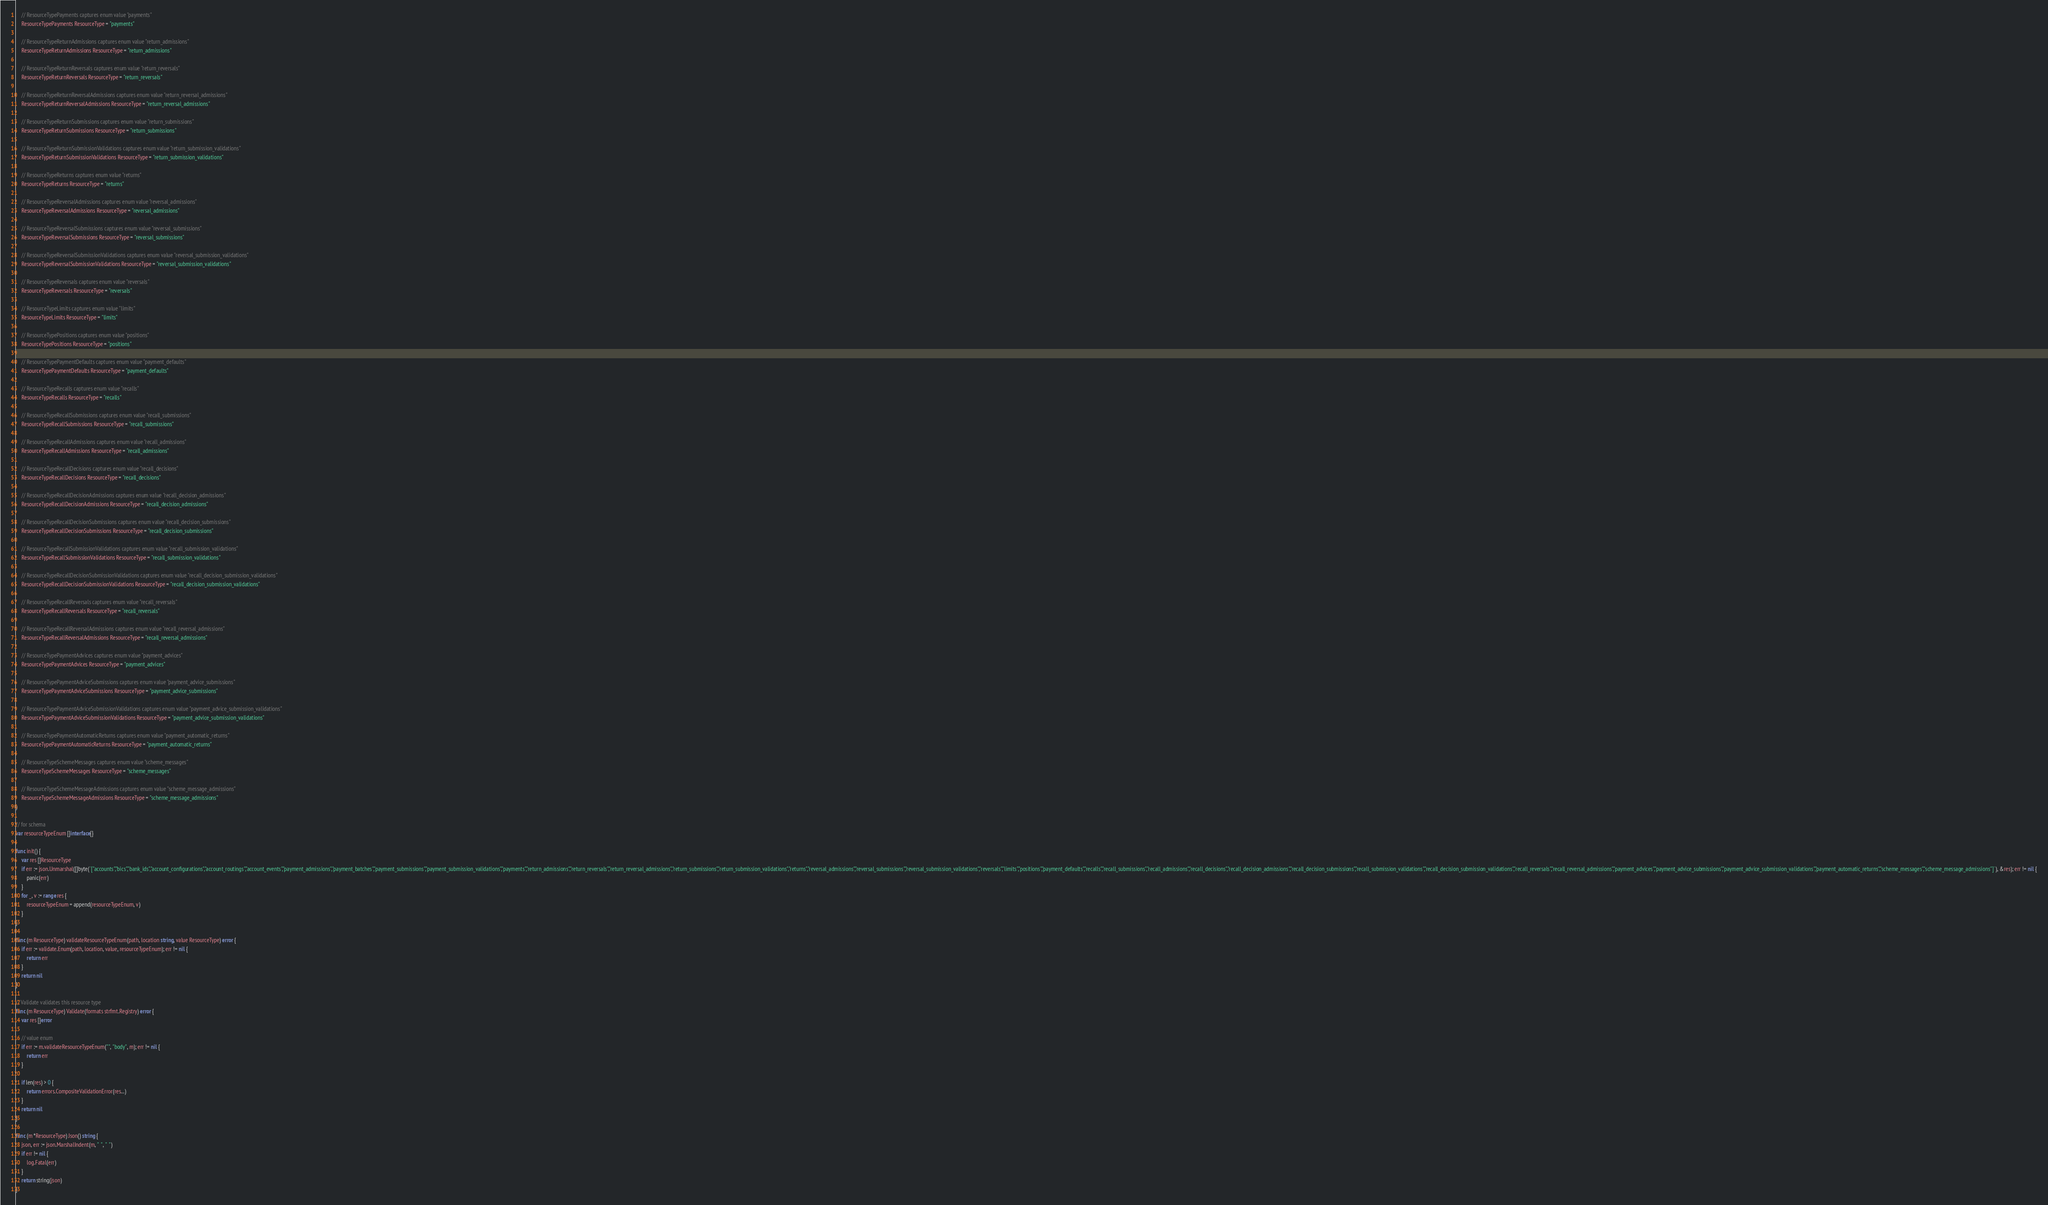<code> <loc_0><loc_0><loc_500><loc_500><_Go_>
	// ResourceTypePayments captures enum value "payments"
	ResourceTypePayments ResourceType = "payments"

	// ResourceTypeReturnAdmissions captures enum value "return_admissions"
	ResourceTypeReturnAdmissions ResourceType = "return_admissions"

	// ResourceTypeReturnReversals captures enum value "return_reversals"
	ResourceTypeReturnReversals ResourceType = "return_reversals"

	// ResourceTypeReturnReversalAdmissions captures enum value "return_reversal_admissions"
	ResourceTypeReturnReversalAdmissions ResourceType = "return_reversal_admissions"

	// ResourceTypeReturnSubmissions captures enum value "return_submissions"
	ResourceTypeReturnSubmissions ResourceType = "return_submissions"

	// ResourceTypeReturnSubmissionValidations captures enum value "return_submission_validations"
	ResourceTypeReturnSubmissionValidations ResourceType = "return_submission_validations"

	// ResourceTypeReturns captures enum value "returns"
	ResourceTypeReturns ResourceType = "returns"

	// ResourceTypeReversalAdmissions captures enum value "reversal_admissions"
	ResourceTypeReversalAdmissions ResourceType = "reversal_admissions"

	// ResourceTypeReversalSubmissions captures enum value "reversal_submissions"
	ResourceTypeReversalSubmissions ResourceType = "reversal_submissions"

	// ResourceTypeReversalSubmissionValidations captures enum value "reversal_submission_validations"
	ResourceTypeReversalSubmissionValidations ResourceType = "reversal_submission_validations"

	// ResourceTypeReversals captures enum value "reversals"
	ResourceTypeReversals ResourceType = "reversals"

	// ResourceTypeLimits captures enum value "limits"
	ResourceTypeLimits ResourceType = "limits"

	// ResourceTypePositions captures enum value "positions"
	ResourceTypePositions ResourceType = "positions"

	// ResourceTypePaymentDefaults captures enum value "payment_defaults"
	ResourceTypePaymentDefaults ResourceType = "payment_defaults"

	// ResourceTypeRecalls captures enum value "recalls"
	ResourceTypeRecalls ResourceType = "recalls"

	// ResourceTypeRecallSubmissions captures enum value "recall_submissions"
	ResourceTypeRecallSubmissions ResourceType = "recall_submissions"

	// ResourceTypeRecallAdmissions captures enum value "recall_admissions"
	ResourceTypeRecallAdmissions ResourceType = "recall_admissions"

	// ResourceTypeRecallDecisions captures enum value "recall_decisions"
	ResourceTypeRecallDecisions ResourceType = "recall_decisions"

	// ResourceTypeRecallDecisionAdmissions captures enum value "recall_decision_admissions"
	ResourceTypeRecallDecisionAdmissions ResourceType = "recall_decision_admissions"

	// ResourceTypeRecallDecisionSubmissions captures enum value "recall_decision_submissions"
	ResourceTypeRecallDecisionSubmissions ResourceType = "recall_decision_submissions"

	// ResourceTypeRecallSubmissionValidations captures enum value "recall_submission_validations"
	ResourceTypeRecallSubmissionValidations ResourceType = "recall_submission_validations"

	// ResourceTypeRecallDecisionSubmissionValidations captures enum value "recall_decision_submission_validations"
	ResourceTypeRecallDecisionSubmissionValidations ResourceType = "recall_decision_submission_validations"

	// ResourceTypeRecallReversals captures enum value "recall_reversals"
	ResourceTypeRecallReversals ResourceType = "recall_reversals"

	// ResourceTypeRecallReversalAdmissions captures enum value "recall_reversal_admissions"
	ResourceTypeRecallReversalAdmissions ResourceType = "recall_reversal_admissions"

	// ResourceTypePaymentAdvices captures enum value "payment_advices"
	ResourceTypePaymentAdvices ResourceType = "payment_advices"

	// ResourceTypePaymentAdviceSubmissions captures enum value "payment_advice_submissions"
	ResourceTypePaymentAdviceSubmissions ResourceType = "payment_advice_submissions"

	// ResourceTypePaymentAdviceSubmissionValidations captures enum value "payment_advice_submission_validations"
	ResourceTypePaymentAdviceSubmissionValidations ResourceType = "payment_advice_submission_validations"

	// ResourceTypePaymentAutomaticReturns captures enum value "payment_automatic_returns"
	ResourceTypePaymentAutomaticReturns ResourceType = "payment_automatic_returns"

	// ResourceTypeSchemeMessages captures enum value "scheme_messages"
	ResourceTypeSchemeMessages ResourceType = "scheme_messages"

	// ResourceTypeSchemeMessageAdmissions captures enum value "scheme_message_admissions"
	ResourceTypeSchemeMessageAdmissions ResourceType = "scheme_message_admissions"
)

// for schema
var resourceTypeEnum []interface{}

func init() {
	var res []ResourceType
	if err := json.Unmarshal([]byte(`["accounts","bics","bank_ids","account_configurations","account_routings","account_events","payment_admissions","payment_batches","payment_submissions","payment_submission_validations","payments","return_admissions","return_reversals","return_reversal_admissions","return_submissions","return_submission_validations","returns","reversal_admissions","reversal_submissions","reversal_submission_validations","reversals","limits","positions","payment_defaults","recalls","recall_submissions","recall_admissions","recall_decisions","recall_decision_admissions","recall_decision_submissions","recall_submission_validations","recall_decision_submission_validations","recall_reversals","recall_reversal_admissions","payment_advices","payment_advice_submissions","payment_advice_submission_validations","payment_automatic_returns","scheme_messages","scheme_message_admissions"]`), &res); err != nil {
		panic(err)
	}
	for _, v := range res {
		resourceTypeEnum = append(resourceTypeEnum, v)
	}
}

func (m ResourceType) validateResourceTypeEnum(path, location string, value ResourceType) error {
	if err := validate.Enum(path, location, value, resourceTypeEnum); err != nil {
		return err
	}
	return nil
}

// Validate validates this resource type
func (m ResourceType) Validate(formats strfmt.Registry) error {
	var res []error

	// value enum
	if err := m.validateResourceTypeEnum("", "body", m); err != nil {
		return err
	}

	if len(res) > 0 {
		return errors.CompositeValidationError(res...)
	}
	return nil
}

func (m *ResourceType) Json() string {
	json, err := json.MarshalIndent(m, "  ", "  ")
	if err != nil {
		log.Fatal(err)
	}
	return string(json)
}
</code> 